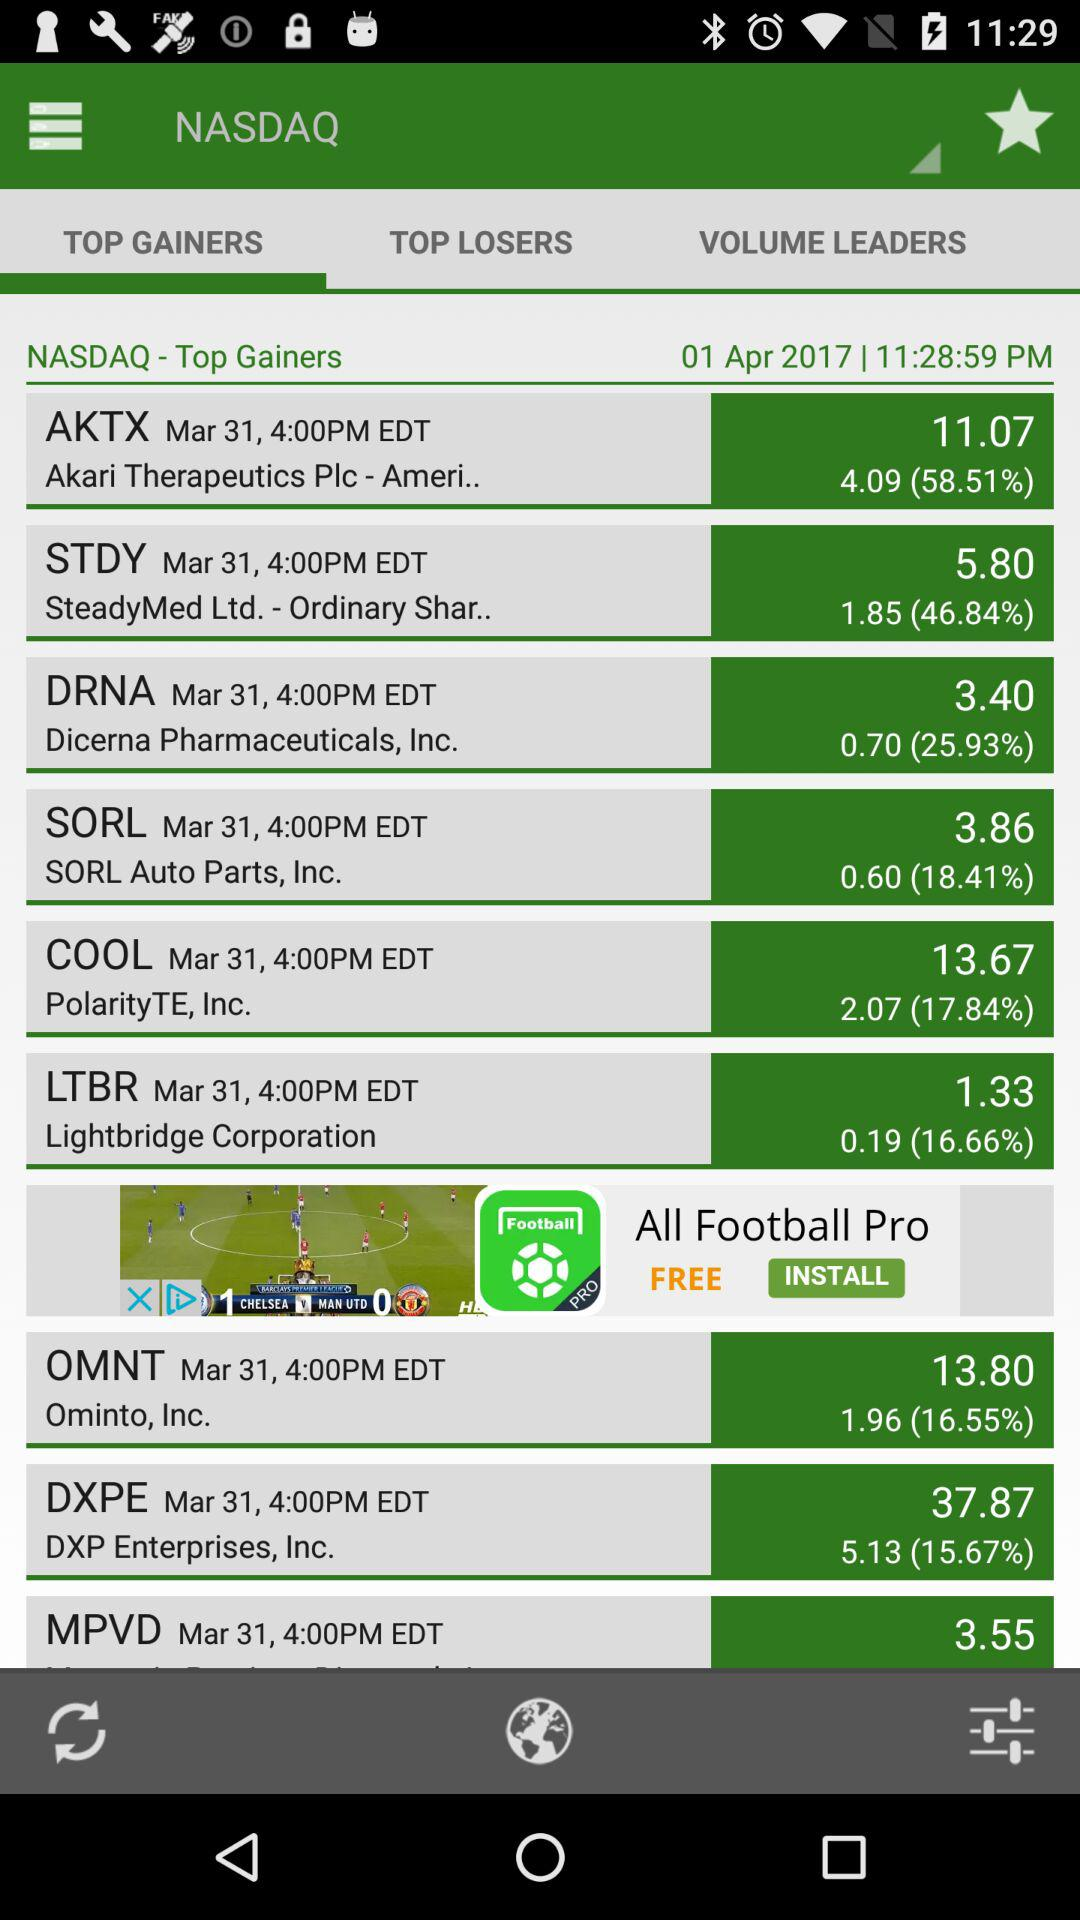Which tab has been selected? The tab "TOP GAINERS" has been selected. 